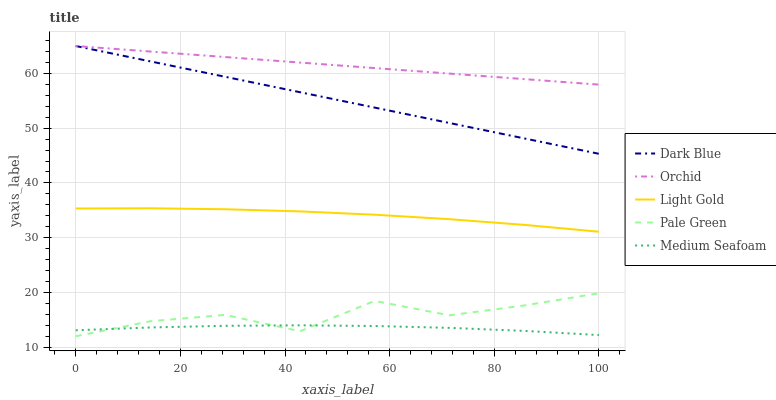Does Medium Seafoam have the minimum area under the curve?
Answer yes or no. Yes. Does Orchid have the maximum area under the curve?
Answer yes or no. Yes. Does Pale Green have the minimum area under the curve?
Answer yes or no. No. Does Pale Green have the maximum area under the curve?
Answer yes or no. No. Is Orchid the smoothest?
Answer yes or no. Yes. Is Pale Green the roughest?
Answer yes or no. Yes. Is Light Gold the smoothest?
Answer yes or no. No. Is Light Gold the roughest?
Answer yes or no. No. Does Pale Green have the lowest value?
Answer yes or no. Yes. Does Light Gold have the lowest value?
Answer yes or no. No. Does Orchid have the highest value?
Answer yes or no. Yes. Does Pale Green have the highest value?
Answer yes or no. No. Is Medium Seafoam less than Light Gold?
Answer yes or no. Yes. Is Orchid greater than Medium Seafoam?
Answer yes or no. Yes. Does Pale Green intersect Medium Seafoam?
Answer yes or no. Yes. Is Pale Green less than Medium Seafoam?
Answer yes or no. No. Is Pale Green greater than Medium Seafoam?
Answer yes or no. No. Does Medium Seafoam intersect Light Gold?
Answer yes or no. No. 